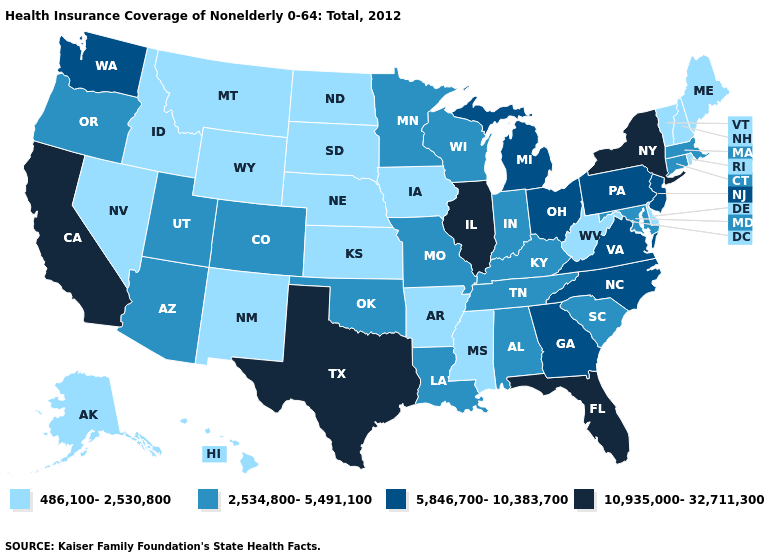What is the highest value in the MidWest ?
Answer briefly. 10,935,000-32,711,300. What is the lowest value in states that border Missouri?
Concise answer only. 486,100-2,530,800. What is the value of North Carolina?
Quick response, please. 5,846,700-10,383,700. Which states hav the highest value in the Northeast?
Be succinct. New York. How many symbols are there in the legend?
Keep it brief. 4. What is the value of New Hampshire?
Give a very brief answer. 486,100-2,530,800. What is the value of Maryland?
Quick response, please. 2,534,800-5,491,100. What is the value of Louisiana?
Write a very short answer. 2,534,800-5,491,100. Name the states that have a value in the range 2,534,800-5,491,100?
Quick response, please. Alabama, Arizona, Colorado, Connecticut, Indiana, Kentucky, Louisiana, Maryland, Massachusetts, Minnesota, Missouri, Oklahoma, Oregon, South Carolina, Tennessee, Utah, Wisconsin. What is the value of Wisconsin?
Write a very short answer. 2,534,800-5,491,100. Does California have a higher value than Illinois?
Keep it brief. No. What is the highest value in the USA?
Write a very short answer. 10,935,000-32,711,300. What is the value of Louisiana?
Quick response, please. 2,534,800-5,491,100. Does the first symbol in the legend represent the smallest category?
Short answer required. Yes. What is the value of Rhode Island?
Answer briefly. 486,100-2,530,800. 